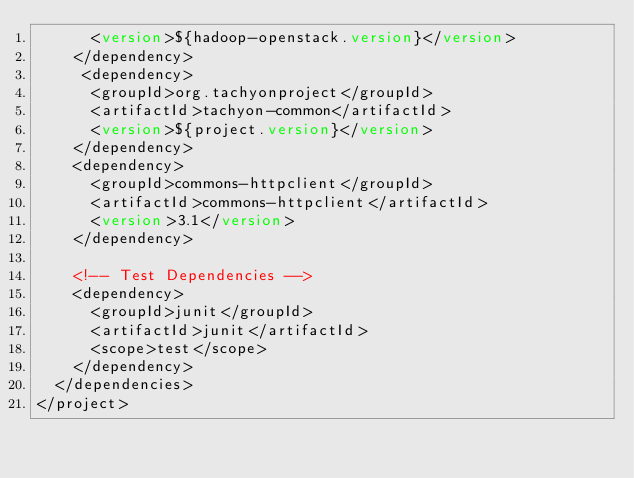<code> <loc_0><loc_0><loc_500><loc_500><_XML_>      <version>${hadoop-openstack.version}</version>
    </dependency>
     <dependency>
      <groupId>org.tachyonproject</groupId>
      <artifactId>tachyon-common</artifactId>
      <version>${project.version}</version>
    </dependency>
    <dependency>
      <groupId>commons-httpclient</groupId>
      <artifactId>commons-httpclient</artifactId>
      <version>3.1</version>
    </dependency>
 
    <!-- Test Dependencies -->
    <dependency>
      <groupId>junit</groupId>
      <artifactId>junit</artifactId>
      <scope>test</scope>
    </dependency>
  </dependencies>
</project>
</code> 